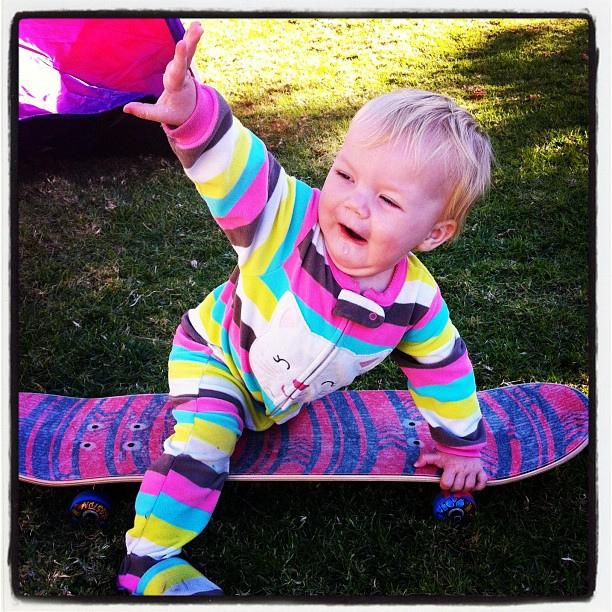Is this baby waving to someone?
Concise answer only. Yes. What animal can been seen in this picture?
Give a very brief answer. Cat. What natural phenomenon looks like this baby's attire?
Answer briefly. Rainbow. 